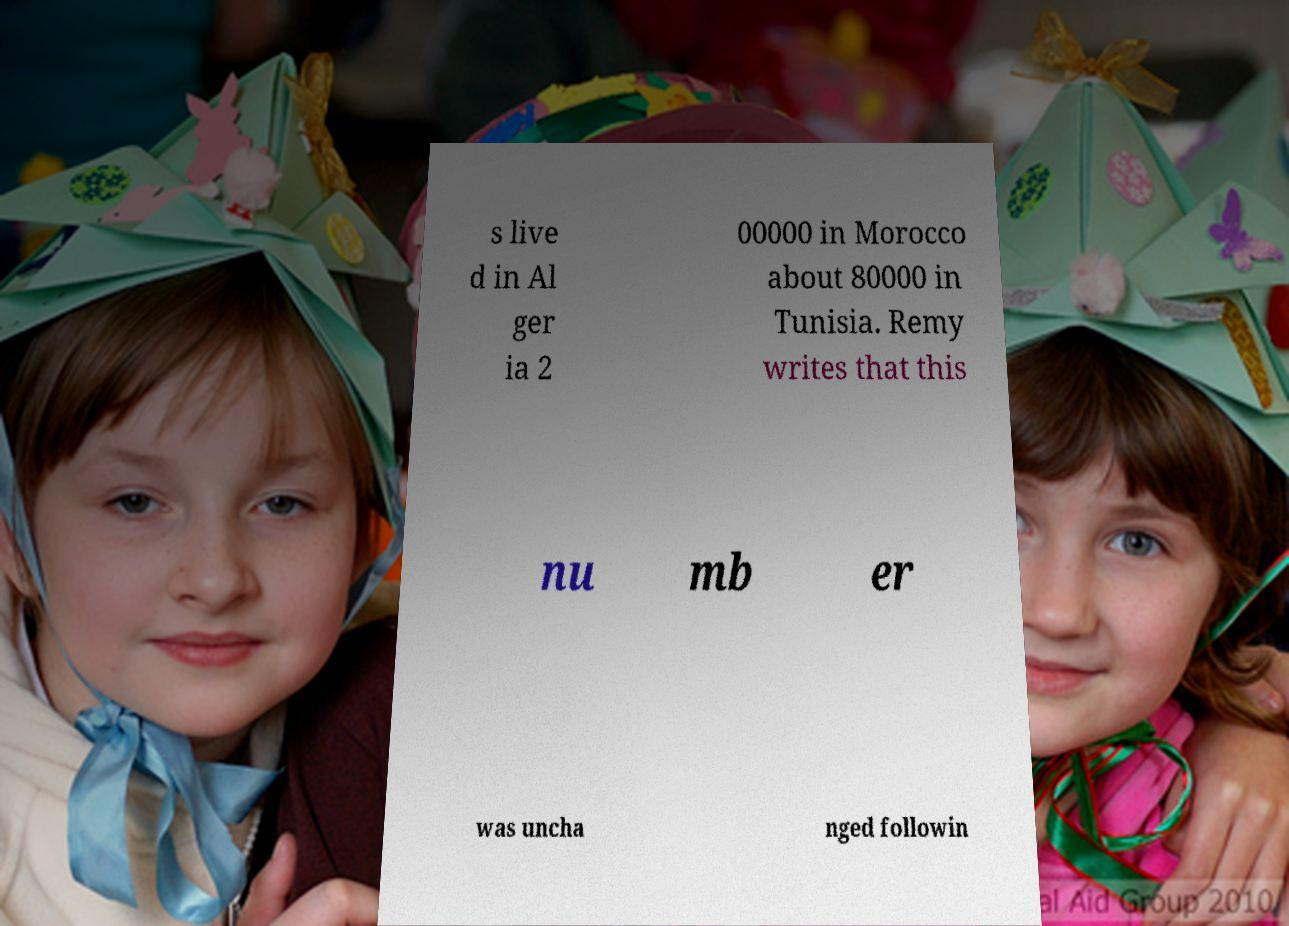I need the written content from this picture converted into text. Can you do that? s live d in Al ger ia 2 00000 in Morocco about 80000 in Tunisia. Remy writes that this nu mb er was uncha nged followin 